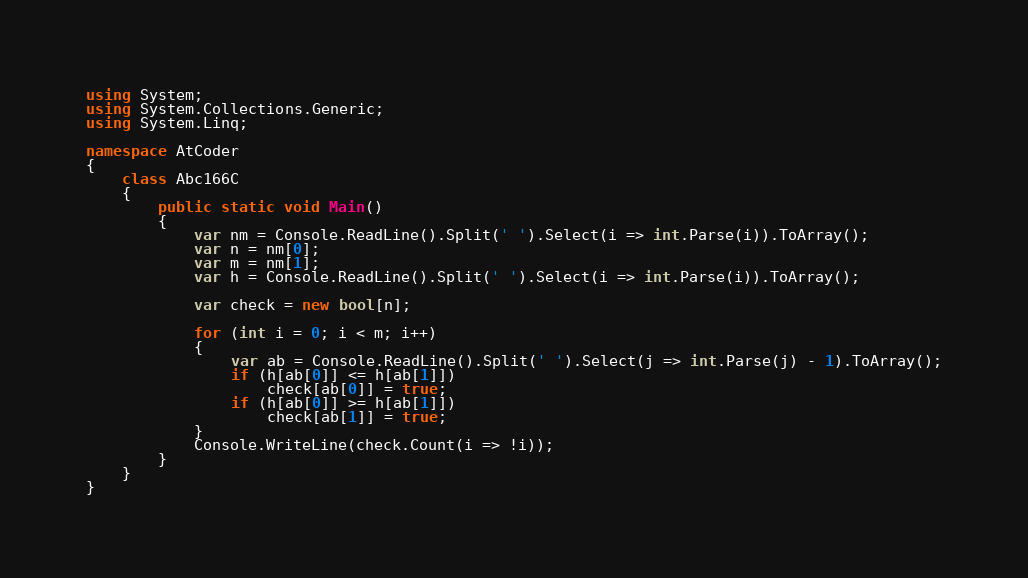Convert code to text. <code><loc_0><loc_0><loc_500><loc_500><_C#_>using System;
using System.Collections.Generic;
using System.Linq;

namespace AtCoder
{
    class Abc166C
    {
        public static void Main()
        {
            var nm = Console.ReadLine().Split(' ').Select(i => int.Parse(i)).ToArray();
            var n = nm[0];
            var m = nm[1];
            var h = Console.ReadLine().Split(' ').Select(i => int.Parse(i)).ToArray();

            var check = new bool[n];

            for (int i = 0; i < m; i++)
            {
                var ab = Console.ReadLine().Split(' ').Select(j => int.Parse(j) - 1).ToArray();
                if (h[ab[0]] <= h[ab[1]])
                    check[ab[0]] = true;
                if (h[ab[0]] >= h[ab[1]])
                    check[ab[1]] = true;
            }
            Console.WriteLine(check.Count(i => !i));
        }
    }
}</code> 